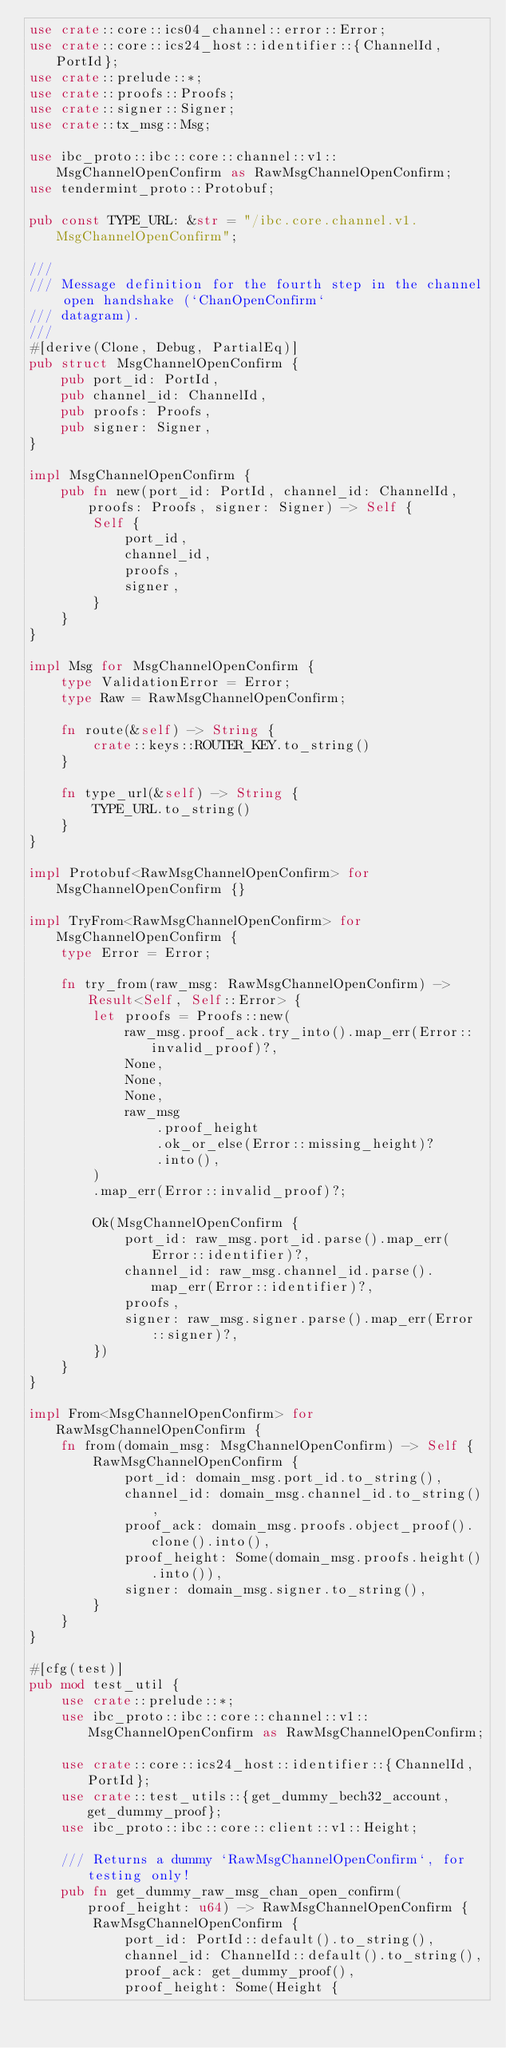<code> <loc_0><loc_0><loc_500><loc_500><_Rust_>use crate::core::ics04_channel::error::Error;
use crate::core::ics24_host::identifier::{ChannelId, PortId};
use crate::prelude::*;
use crate::proofs::Proofs;
use crate::signer::Signer;
use crate::tx_msg::Msg;

use ibc_proto::ibc::core::channel::v1::MsgChannelOpenConfirm as RawMsgChannelOpenConfirm;
use tendermint_proto::Protobuf;

pub const TYPE_URL: &str = "/ibc.core.channel.v1.MsgChannelOpenConfirm";

///
/// Message definition for the fourth step in the channel open handshake (`ChanOpenConfirm`
/// datagram).
///
#[derive(Clone, Debug, PartialEq)]
pub struct MsgChannelOpenConfirm {
    pub port_id: PortId,
    pub channel_id: ChannelId,
    pub proofs: Proofs,
    pub signer: Signer,
}

impl MsgChannelOpenConfirm {
    pub fn new(port_id: PortId, channel_id: ChannelId, proofs: Proofs, signer: Signer) -> Self {
        Self {
            port_id,
            channel_id,
            proofs,
            signer,
        }
    }
}

impl Msg for MsgChannelOpenConfirm {
    type ValidationError = Error;
    type Raw = RawMsgChannelOpenConfirm;

    fn route(&self) -> String {
        crate::keys::ROUTER_KEY.to_string()
    }

    fn type_url(&self) -> String {
        TYPE_URL.to_string()
    }
}

impl Protobuf<RawMsgChannelOpenConfirm> for MsgChannelOpenConfirm {}

impl TryFrom<RawMsgChannelOpenConfirm> for MsgChannelOpenConfirm {
    type Error = Error;

    fn try_from(raw_msg: RawMsgChannelOpenConfirm) -> Result<Self, Self::Error> {
        let proofs = Proofs::new(
            raw_msg.proof_ack.try_into().map_err(Error::invalid_proof)?,
            None,
            None,
            None,
            raw_msg
                .proof_height
                .ok_or_else(Error::missing_height)?
                .into(),
        )
        .map_err(Error::invalid_proof)?;

        Ok(MsgChannelOpenConfirm {
            port_id: raw_msg.port_id.parse().map_err(Error::identifier)?,
            channel_id: raw_msg.channel_id.parse().map_err(Error::identifier)?,
            proofs,
            signer: raw_msg.signer.parse().map_err(Error::signer)?,
        })
    }
}

impl From<MsgChannelOpenConfirm> for RawMsgChannelOpenConfirm {
    fn from(domain_msg: MsgChannelOpenConfirm) -> Self {
        RawMsgChannelOpenConfirm {
            port_id: domain_msg.port_id.to_string(),
            channel_id: domain_msg.channel_id.to_string(),
            proof_ack: domain_msg.proofs.object_proof().clone().into(),
            proof_height: Some(domain_msg.proofs.height().into()),
            signer: domain_msg.signer.to_string(),
        }
    }
}

#[cfg(test)]
pub mod test_util {
    use crate::prelude::*;
    use ibc_proto::ibc::core::channel::v1::MsgChannelOpenConfirm as RawMsgChannelOpenConfirm;

    use crate::core::ics24_host::identifier::{ChannelId, PortId};
    use crate::test_utils::{get_dummy_bech32_account, get_dummy_proof};
    use ibc_proto::ibc::core::client::v1::Height;

    /// Returns a dummy `RawMsgChannelOpenConfirm`, for testing only!
    pub fn get_dummy_raw_msg_chan_open_confirm(proof_height: u64) -> RawMsgChannelOpenConfirm {
        RawMsgChannelOpenConfirm {
            port_id: PortId::default().to_string(),
            channel_id: ChannelId::default().to_string(),
            proof_ack: get_dummy_proof(),
            proof_height: Some(Height {</code> 